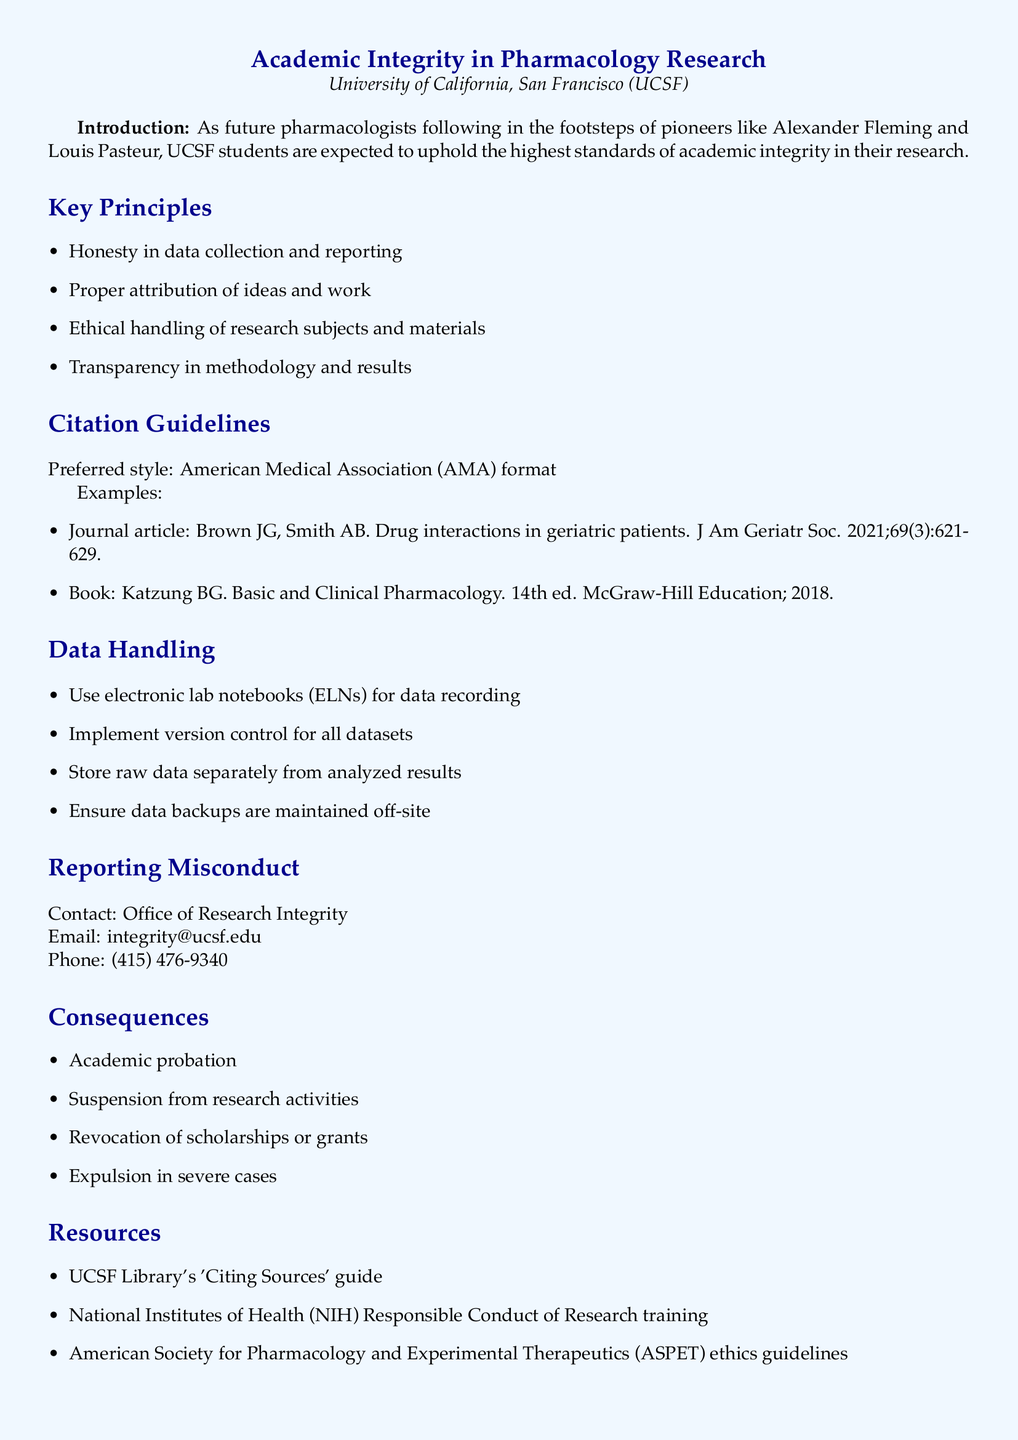What university is mentioned in the document? The document specifically states the university associated with the academic integrity policy.
Answer: University of California, San Francisco (UCSF) What is the preferred citation style mentioned? The document outlines the preferred citation style for pharmacology research.
Answer: American Medical Association (AMA) format How many key principles are listed in the document? You can find the number of key principles listed under the "Key Principles" section.
Answer: Four What email should be contacted for reporting misconduct? The document specifies the email address for reporting academic misconduct.
Answer: integrity@ucsf.edu What consequence is listed for severe cases of misconduct? One consequence for severe cases of misconduct is mentioned in the "Consequences" section.
Answer: Expulsion What resource is provided for 'Citing Sources'? The document lists a resource specifically for citing sources related to academic integrity.
Answer: UCSF Library's 'Citing Sources' guide Explain what should be maintained off-site according to data handling guidelines. The document includes a specific guideline regarding the storage of data backups.
Answer: Data backups What historical figures are mentioned as role models in the introduction? The introduction references two specific historical figures in pharmacology.
Answer: Alexander Fleming and Louis Pasteur What is the phone number for the Office of Research Integrity? The document provides a specific phone number for contacting the Office of Research Integrity.
Answer: (415) 476-9340 